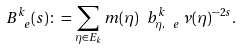<formula> <loc_0><loc_0><loc_500><loc_500>B ^ { k } _ { \ e } ( s ) \colon = \sum _ { \eta \in E _ { k } } m ( \eta ) \ b ^ { k } _ { \eta , \ e } \, \nu ( \eta ) ^ { - 2 s } .</formula> 